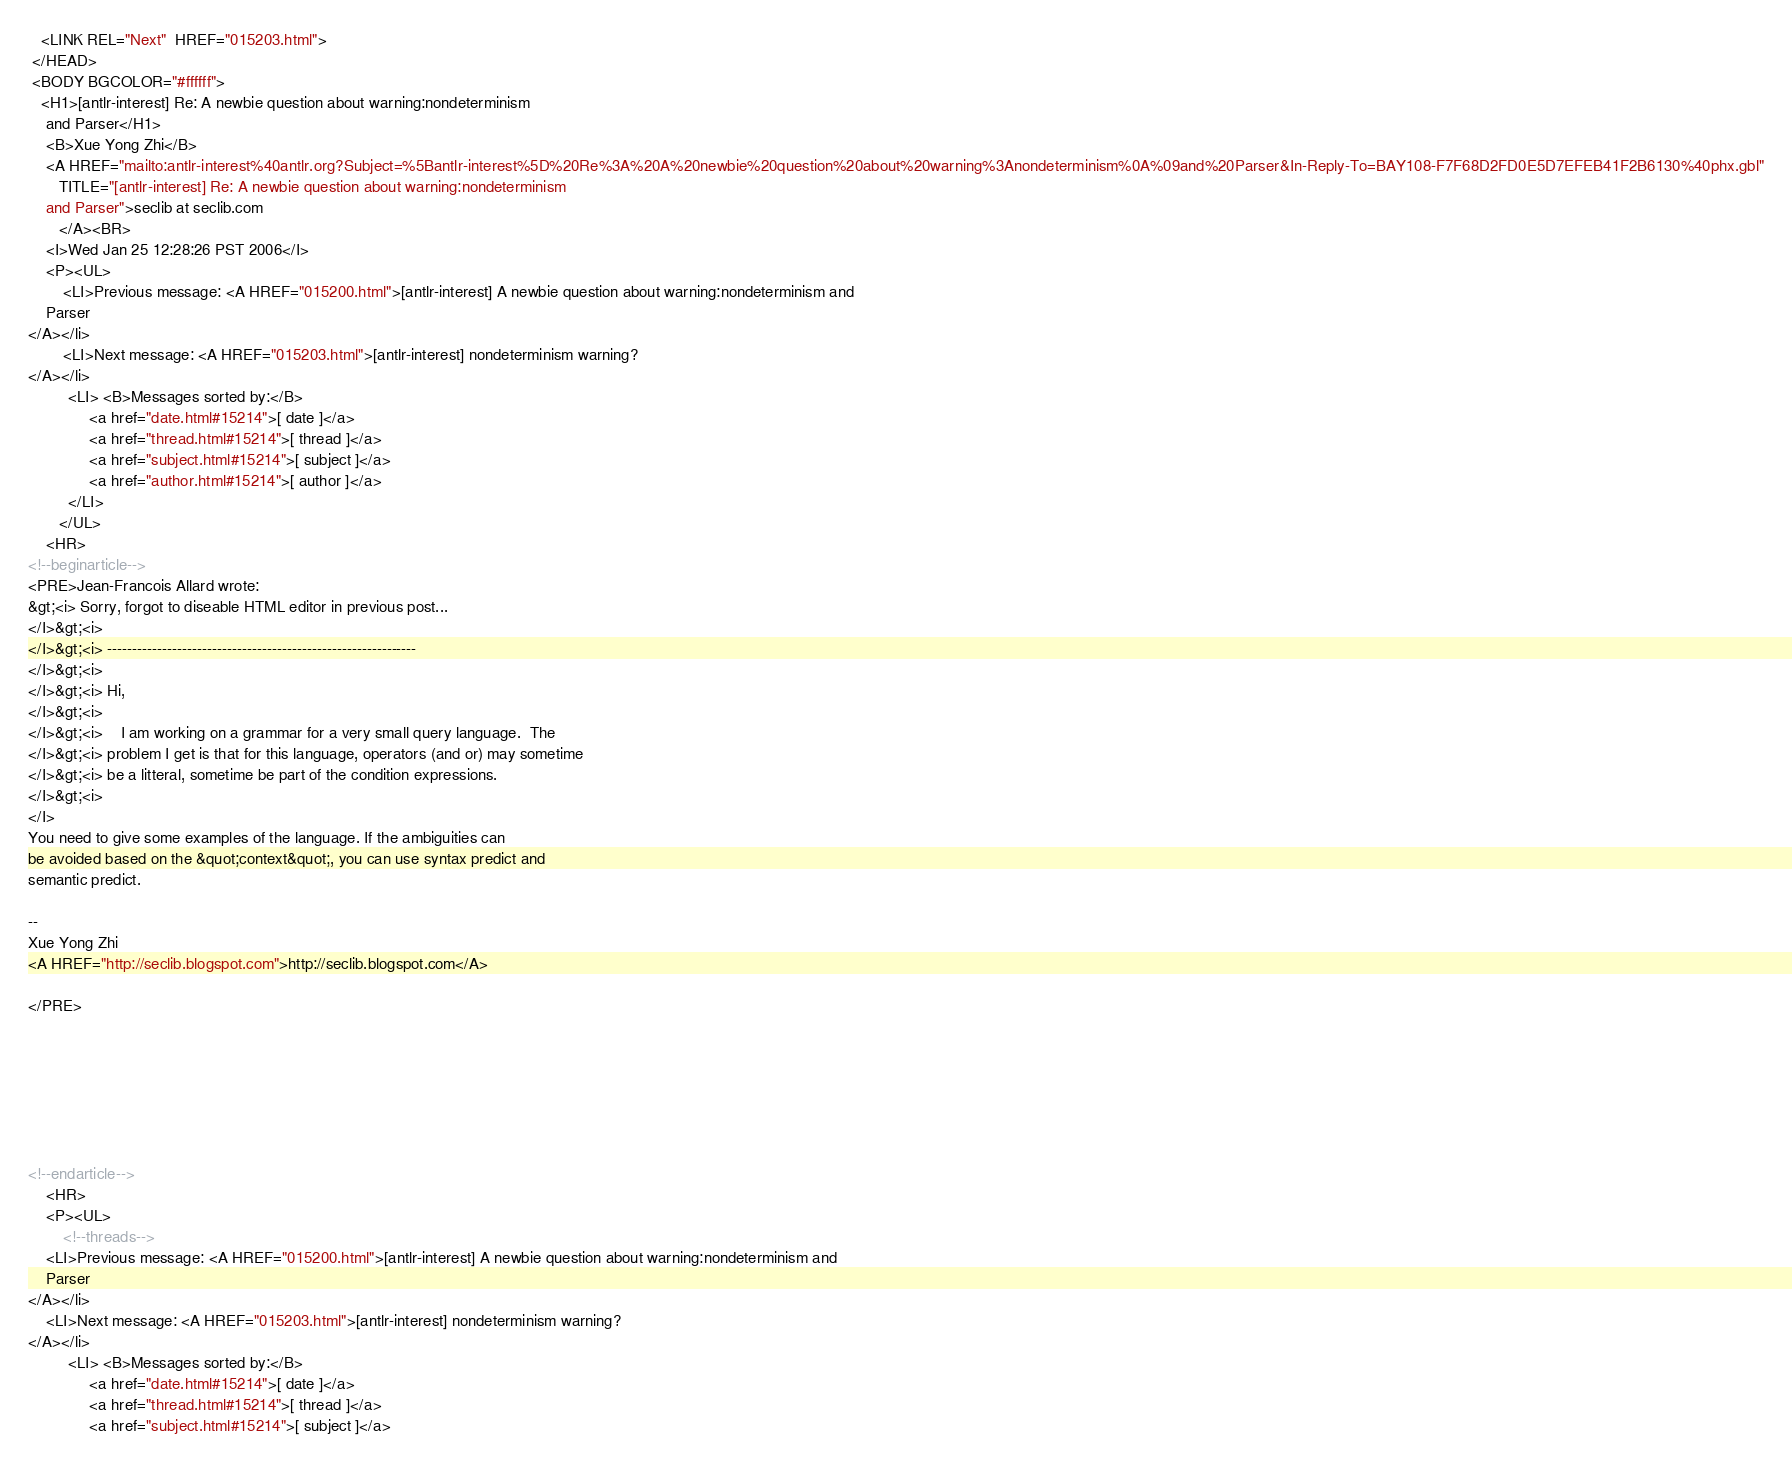<code> <loc_0><loc_0><loc_500><loc_500><_HTML_>   <LINK REL="Next"  HREF="015203.html">
 </HEAD>
 <BODY BGCOLOR="#ffffff">
   <H1>[antlr-interest] Re: A newbie question about warning:nondeterminism
	and Parser</H1>
    <B>Xue Yong Zhi</B> 
    <A HREF="mailto:antlr-interest%40antlr.org?Subject=%5Bantlr-interest%5D%20Re%3A%20A%20newbie%20question%20about%20warning%3Anondeterminism%0A%09and%20Parser&In-Reply-To=BAY108-F7F68D2FD0E5D7EFEB41F2B6130%40phx.gbl"
       TITLE="[antlr-interest] Re: A newbie question about warning:nondeterminism
	and Parser">seclib at seclib.com
       </A><BR>
    <I>Wed Jan 25 12:28:26 PST 2006</I>
    <P><UL>
        <LI>Previous message: <A HREF="015200.html">[antlr-interest] A newbie question about warning:nondeterminism and
	Parser
</A></li>
        <LI>Next message: <A HREF="015203.html">[antlr-interest] nondeterminism warning?
</A></li>
         <LI> <B>Messages sorted by:</B> 
              <a href="date.html#15214">[ date ]</a>
              <a href="thread.html#15214">[ thread ]</a>
              <a href="subject.html#15214">[ subject ]</a>
              <a href="author.html#15214">[ author ]</a>
         </LI>
       </UL>
    <HR>  
<!--beginarticle-->
<PRE>Jean-Francois Allard wrote:
&gt;<i> Sorry, forgot to diseable HTML editor in previous post...
</I>&gt;<i> 
</I>&gt;<i> --------------------------------------------------------------
</I>&gt;<i> 
</I>&gt;<i> Hi,
</I>&gt;<i> 
</I>&gt;<i>    I am working on a grammar for a very small query language.  The 
</I>&gt;<i> problem I get is that for this language, operators (and or) may sometime 
</I>&gt;<i> be a litteral, sometime be part of the condition expressions.
</I>&gt;<i> 
</I>
You need to give some examples of the language. If the ambiguities can 
be avoided based on the &quot;context&quot;, you can use syntax predict and 
semantic predict.

-- 
Xue Yong Zhi
<A HREF="http://seclib.blogspot.com">http://seclib.blogspot.com</A>

</PRE>







<!--endarticle-->
    <HR>
    <P><UL>
        <!--threads-->
	<LI>Previous message: <A HREF="015200.html">[antlr-interest] A newbie question about warning:nondeterminism and
	Parser
</A></li>
	<LI>Next message: <A HREF="015203.html">[antlr-interest] nondeterminism warning?
</A></li>
         <LI> <B>Messages sorted by:</B> 
              <a href="date.html#15214">[ date ]</a>
              <a href="thread.html#15214">[ thread ]</a>
              <a href="subject.html#15214">[ subject ]</a></code> 